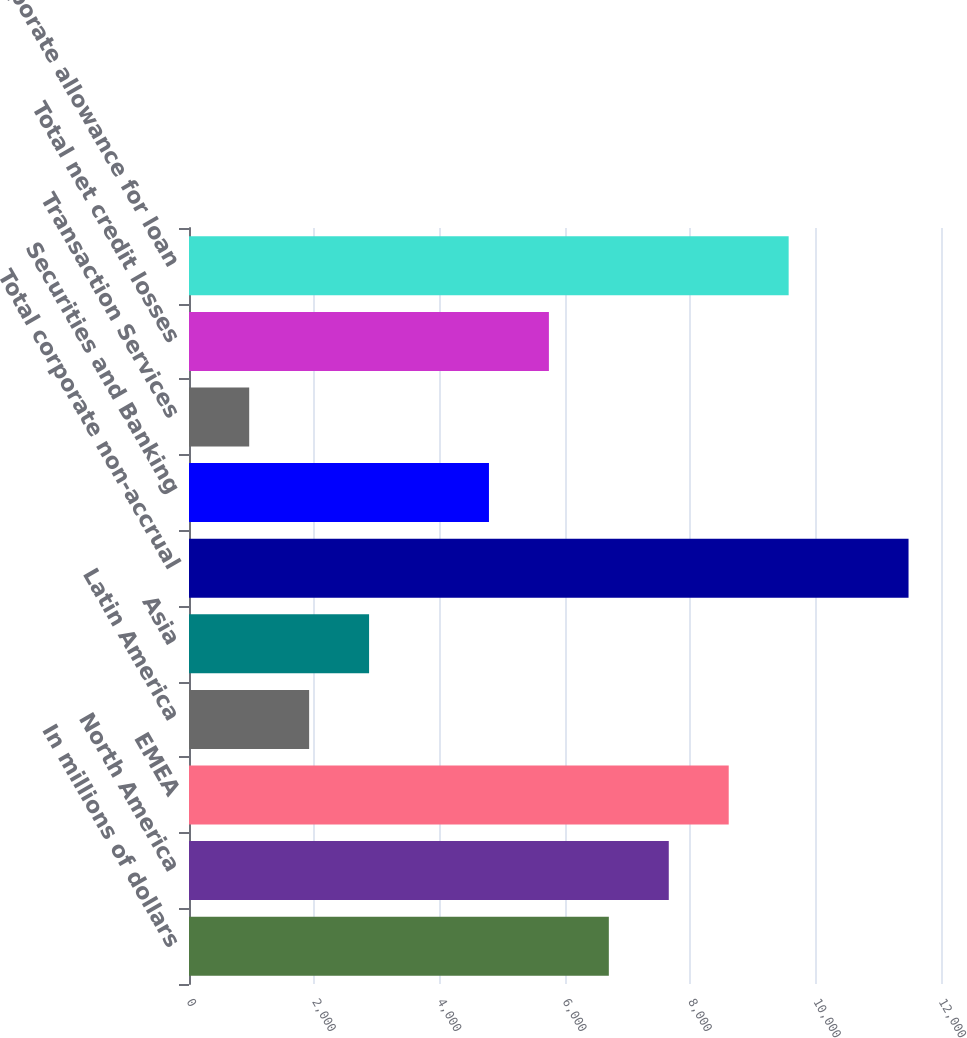<chart> <loc_0><loc_0><loc_500><loc_500><bar_chart><fcel>In millions of dollars<fcel>North America<fcel>EMEA<fcel>Latin America<fcel>Asia<fcel>Total corporate non-accrual<fcel>Securities and Banking<fcel>Transaction Services<fcel>Total net credit losses<fcel>Corporate allowance for loan<nl><fcel>6699.57<fcel>7656.06<fcel>8612.55<fcel>1917.12<fcel>2873.61<fcel>11482<fcel>4786.59<fcel>960.64<fcel>5743.08<fcel>9569.03<nl></chart> 